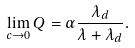<formula> <loc_0><loc_0><loc_500><loc_500>\lim _ { c \rightarrow 0 } Q = \alpha \frac { \lambda _ { d } } { \lambda + \lambda _ { d } } .</formula> 